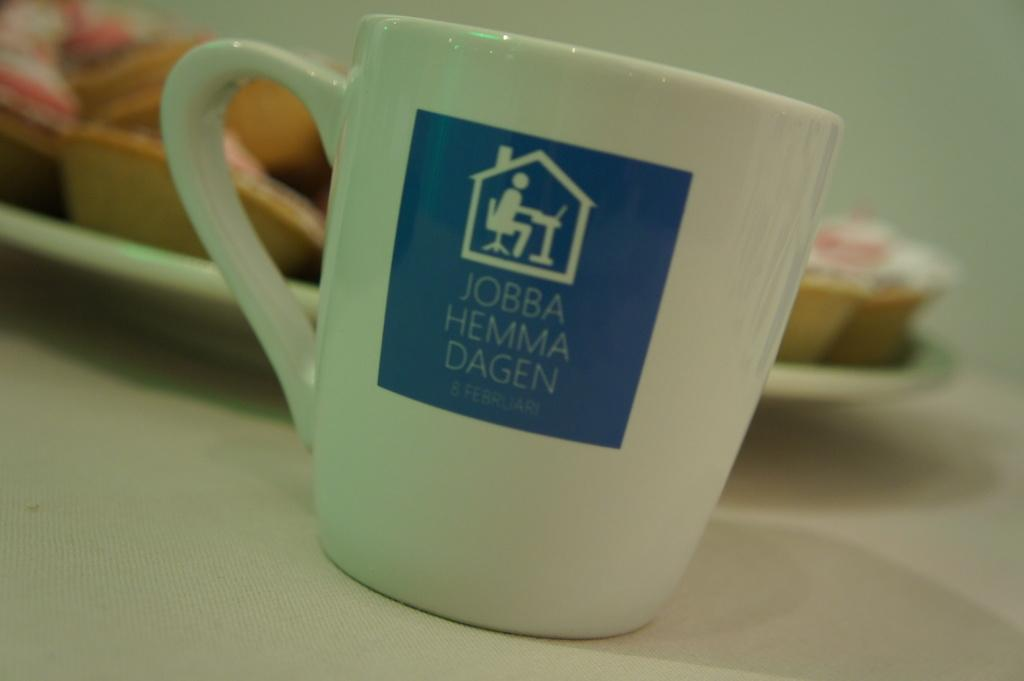<image>
Present a compact description of the photo's key features. A white coffee mug that says Jobba Hemma Dagen on the side. 